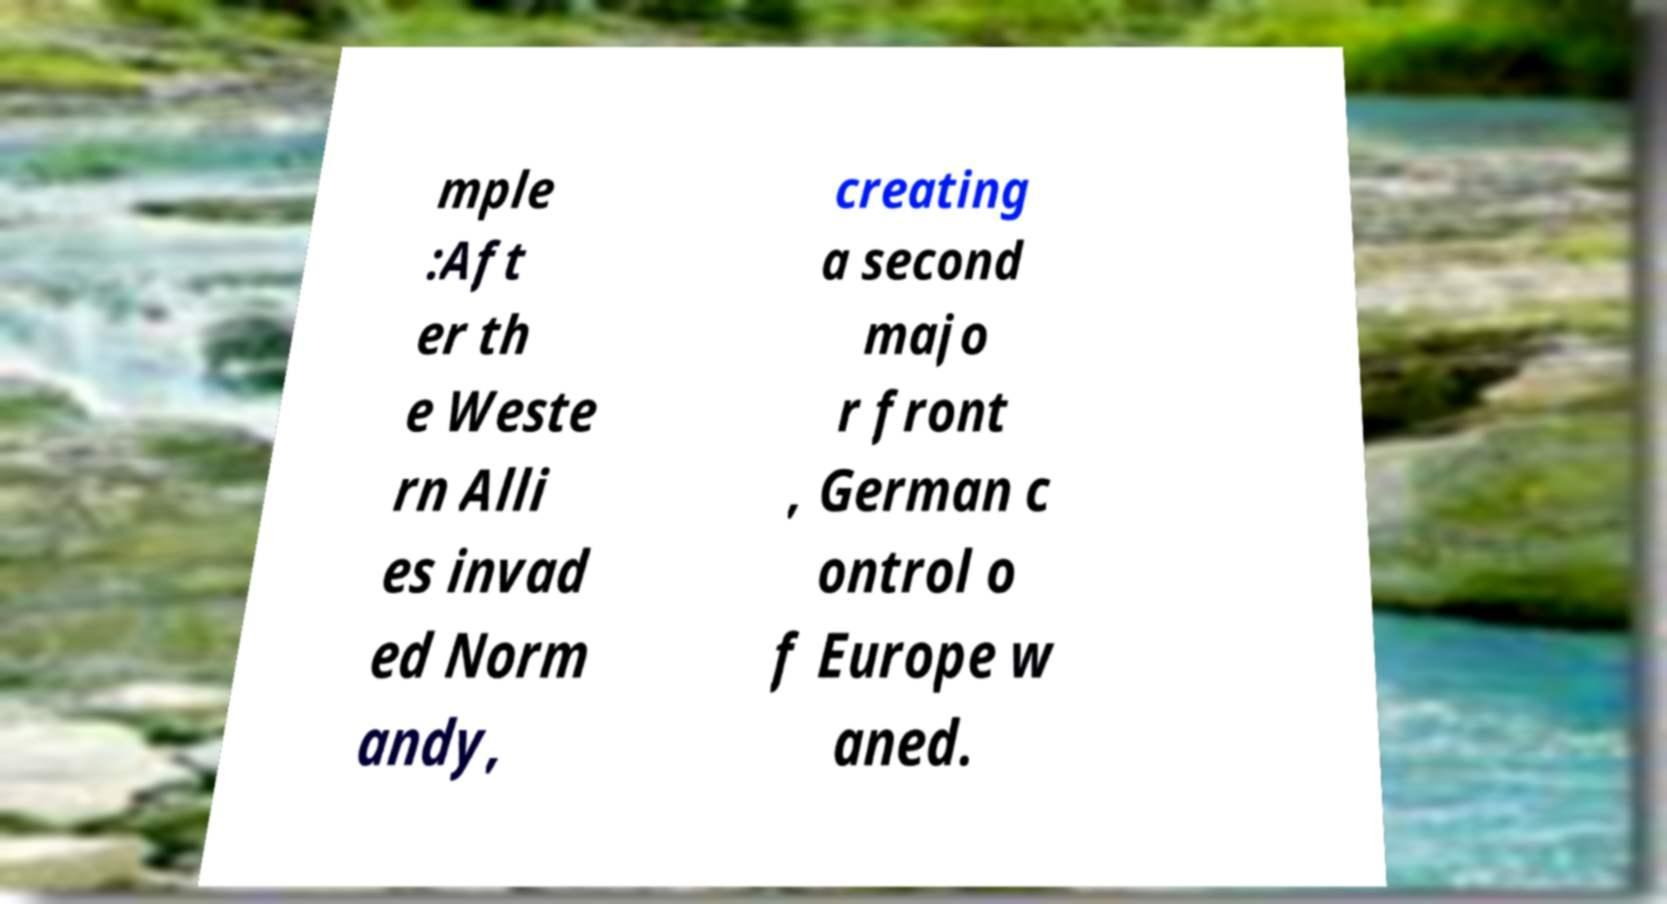Please read and relay the text visible in this image. What does it say? mple :Aft er th e Weste rn Alli es invad ed Norm andy, creating a second majo r front , German c ontrol o f Europe w aned. 